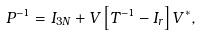Convert formula to latex. <formula><loc_0><loc_0><loc_500><loc_500>P ^ { - 1 } = I _ { 3 N } + V \left [ T ^ { - 1 } - I _ { r } \right ] V ^ { \ast } ,</formula> 